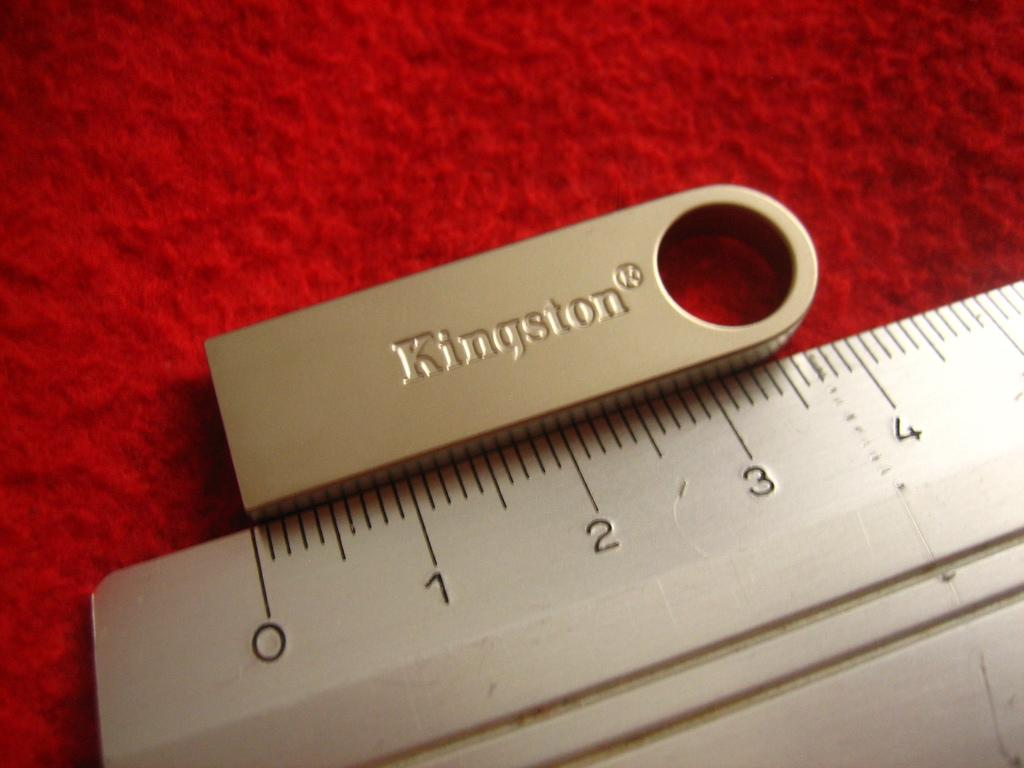Provide a one-sentence caption for the provided image. kingston accessory and meaning ruler sits on the counter. 